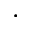<formula> <loc_0><loc_0><loc_500><loc_500>.</formula> 